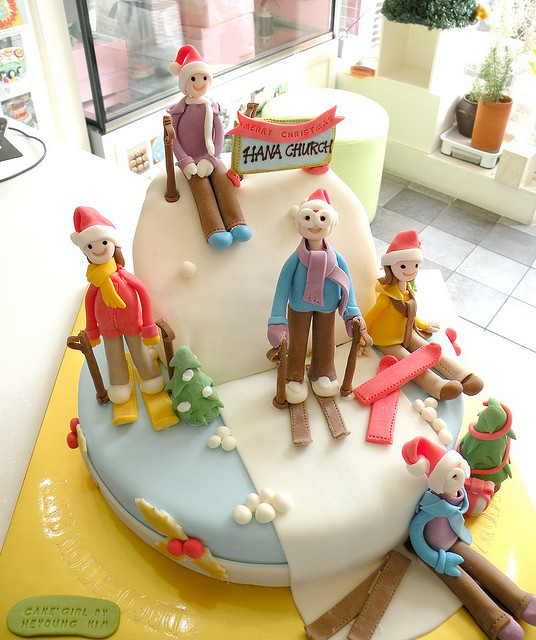Please transcribe the text in this image. HANA CHURCH CHRISTMAS MERRY 